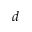<formula> <loc_0><loc_0><loc_500><loc_500>d</formula> 